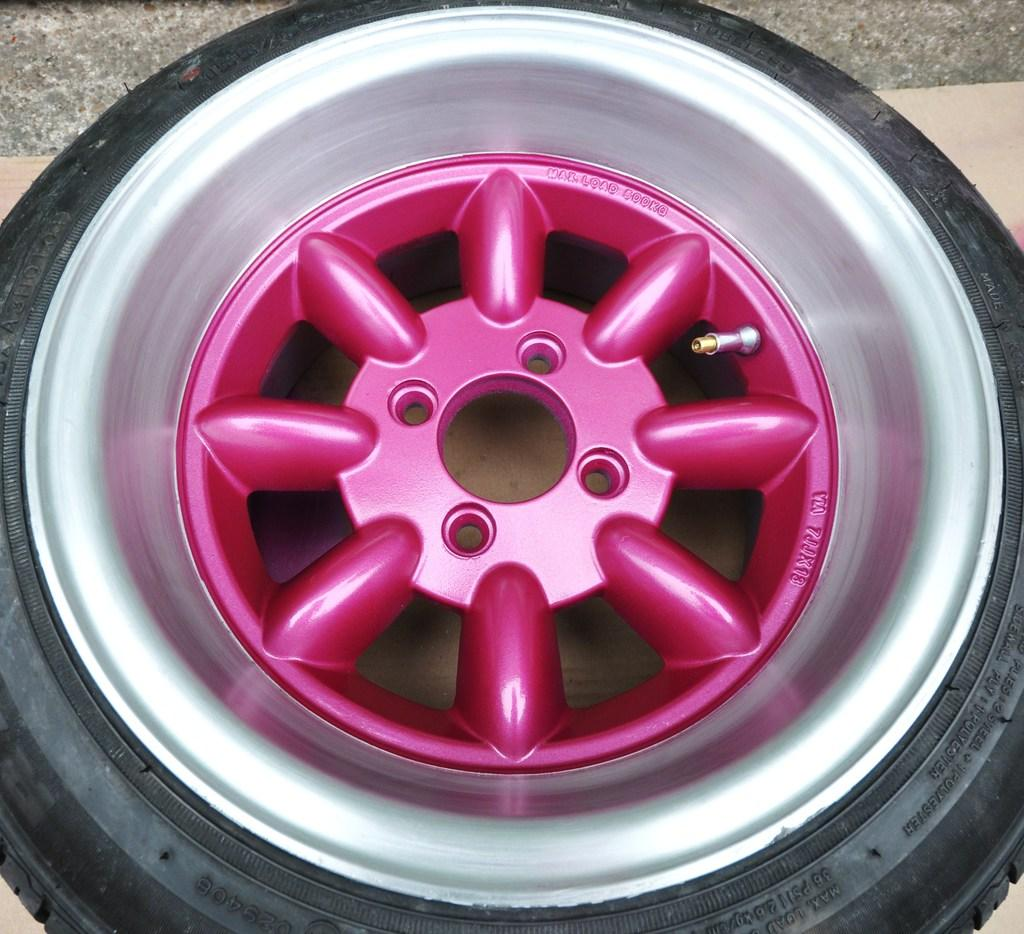What object can be seen in the image that is typically used in vehicles? There is a tire in the image, which is commonly used in vehicles. What color is the tire in the image? The tire is black. What other object related to vehicles is visible in the image? There is a wheel in the image. What colors are used to paint the wheel? The wheel is silver and pink. What can be seen in the background of the image? There is a road in the background of the image. What type of art can be seen on the tray in the image? There is no tray or art present in the image. What material is the tray made of in the image? There is no tray in the image, so it is not possible to determine the material it might be made of. 